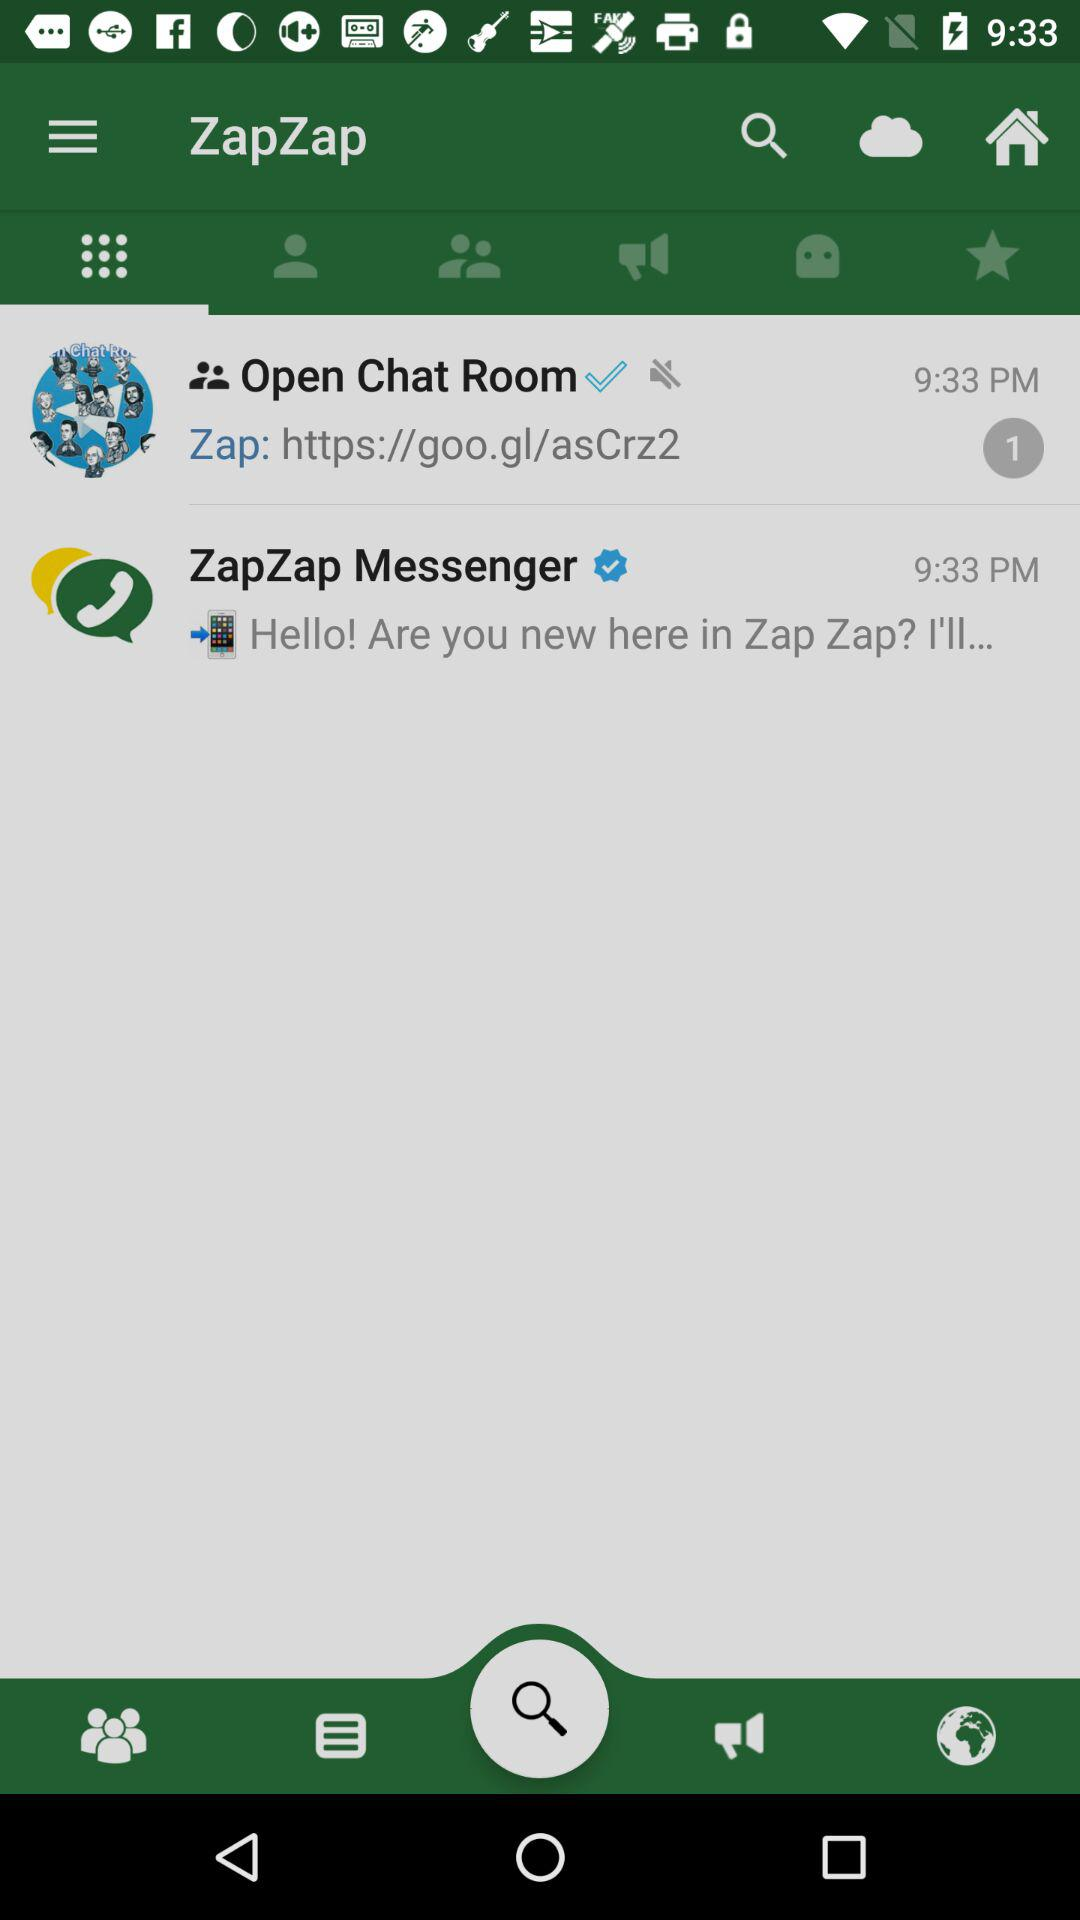What is the mentioned time? The mentioned time is 9:33 p.m. 